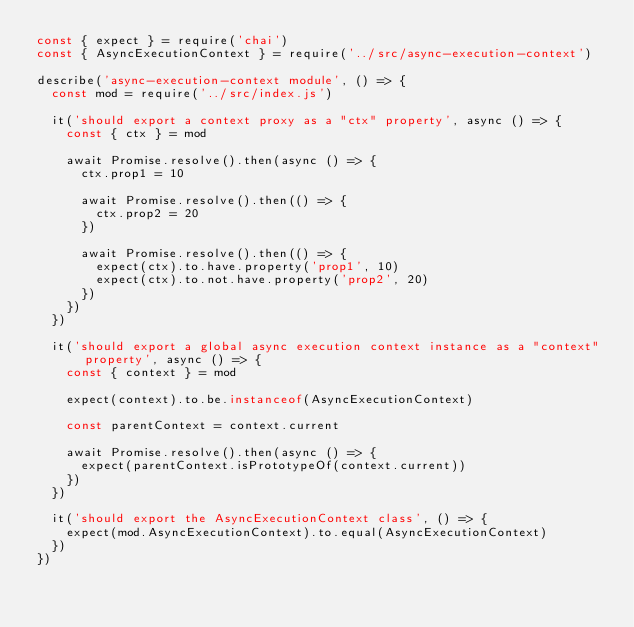Convert code to text. <code><loc_0><loc_0><loc_500><loc_500><_JavaScript_>const { expect } = require('chai')
const { AsyncExecutionContext } = require('../src/async-execution-context')

describe('async-execution-context module', () => {
  const mod = require('../src/index.js')

  it('should export a context proxy as a "ctx" property', async () => {
    const { ctx } = mod

    await Promise.resolve().then(async () => {
      ctx.prop1 = 10

      await Promise.resolve().then(() => {
        ctx.prop2 = 20
      })

      await Promise.resolve().then(() => {
        expect(ctx).to.have.property('prop1', 10)
        expect(ctx).to.not.have.property('prop2', 20)
      })
    })
  })

  it('should export a global async execution context instance as a "context" property', async () => {
    const { context } = mod

    expect(context).to.be.instanceof(AsyncExecutionContext)

    const parentContext = context.current

    await Promise.resolve().then(async () => {
      expect(parentContext.isPrototypeOf(context.current))
    })
  })

  it('should export the AsyncExecutionContext class', () => {
    expect(mod.AsyncExecutionContext).to.equal(AsyncExecutionContext)
  })
})</code> 